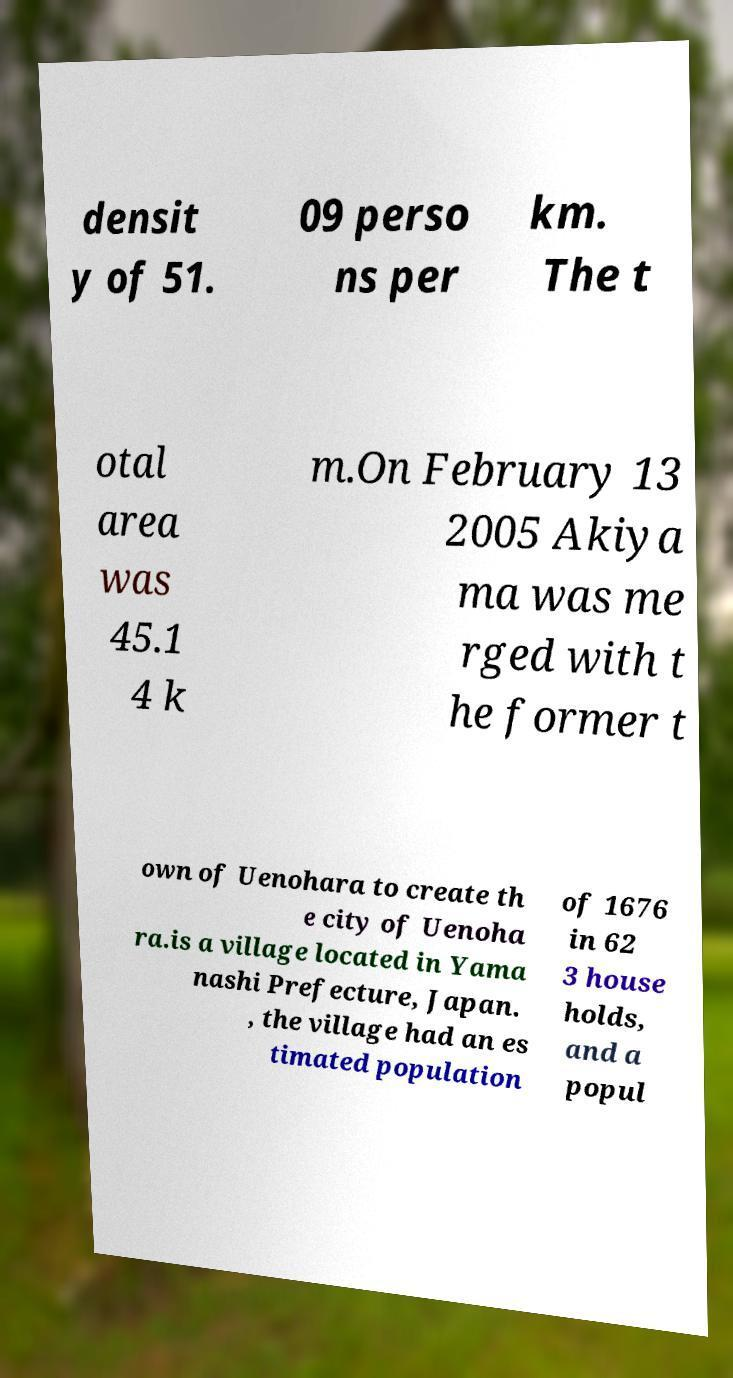I need the written content from this picture converted into text. Can you do that? densit y of 51. 09 perso ns per km. The t otal area was 45.1 4 k m.On February 13 2005 Akiya ma was me rged with t he former t own of Uenohara to create th e city of Uenoha ra.is a village located in Yama nashi Prefecture, Japan. , the village had an es timated population of 1676 in 62 3 house holds, and a popul 